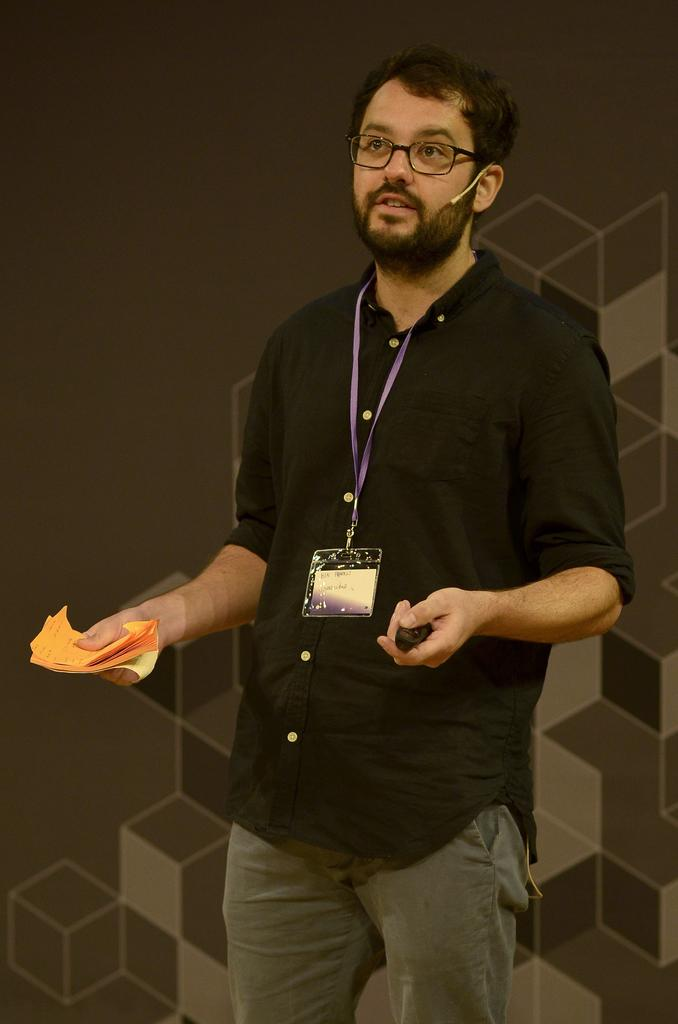What is the man in the image doing? The man is standing in the image. What can be seen on the man's clothing? The man is wearing an ID card and a microphone. What accessory is the man wearing on his face? The man is wearing spectacles. What is the man holding in his hands? The man is holding an object in his hands. Can you see any firemen or lakes in the image? No, there are no firemen or lakes present in the image. What is the man doing with his tongue in the image? There is no mention of the man's tongue in the image, and it cannot be seen in the provided facts. 